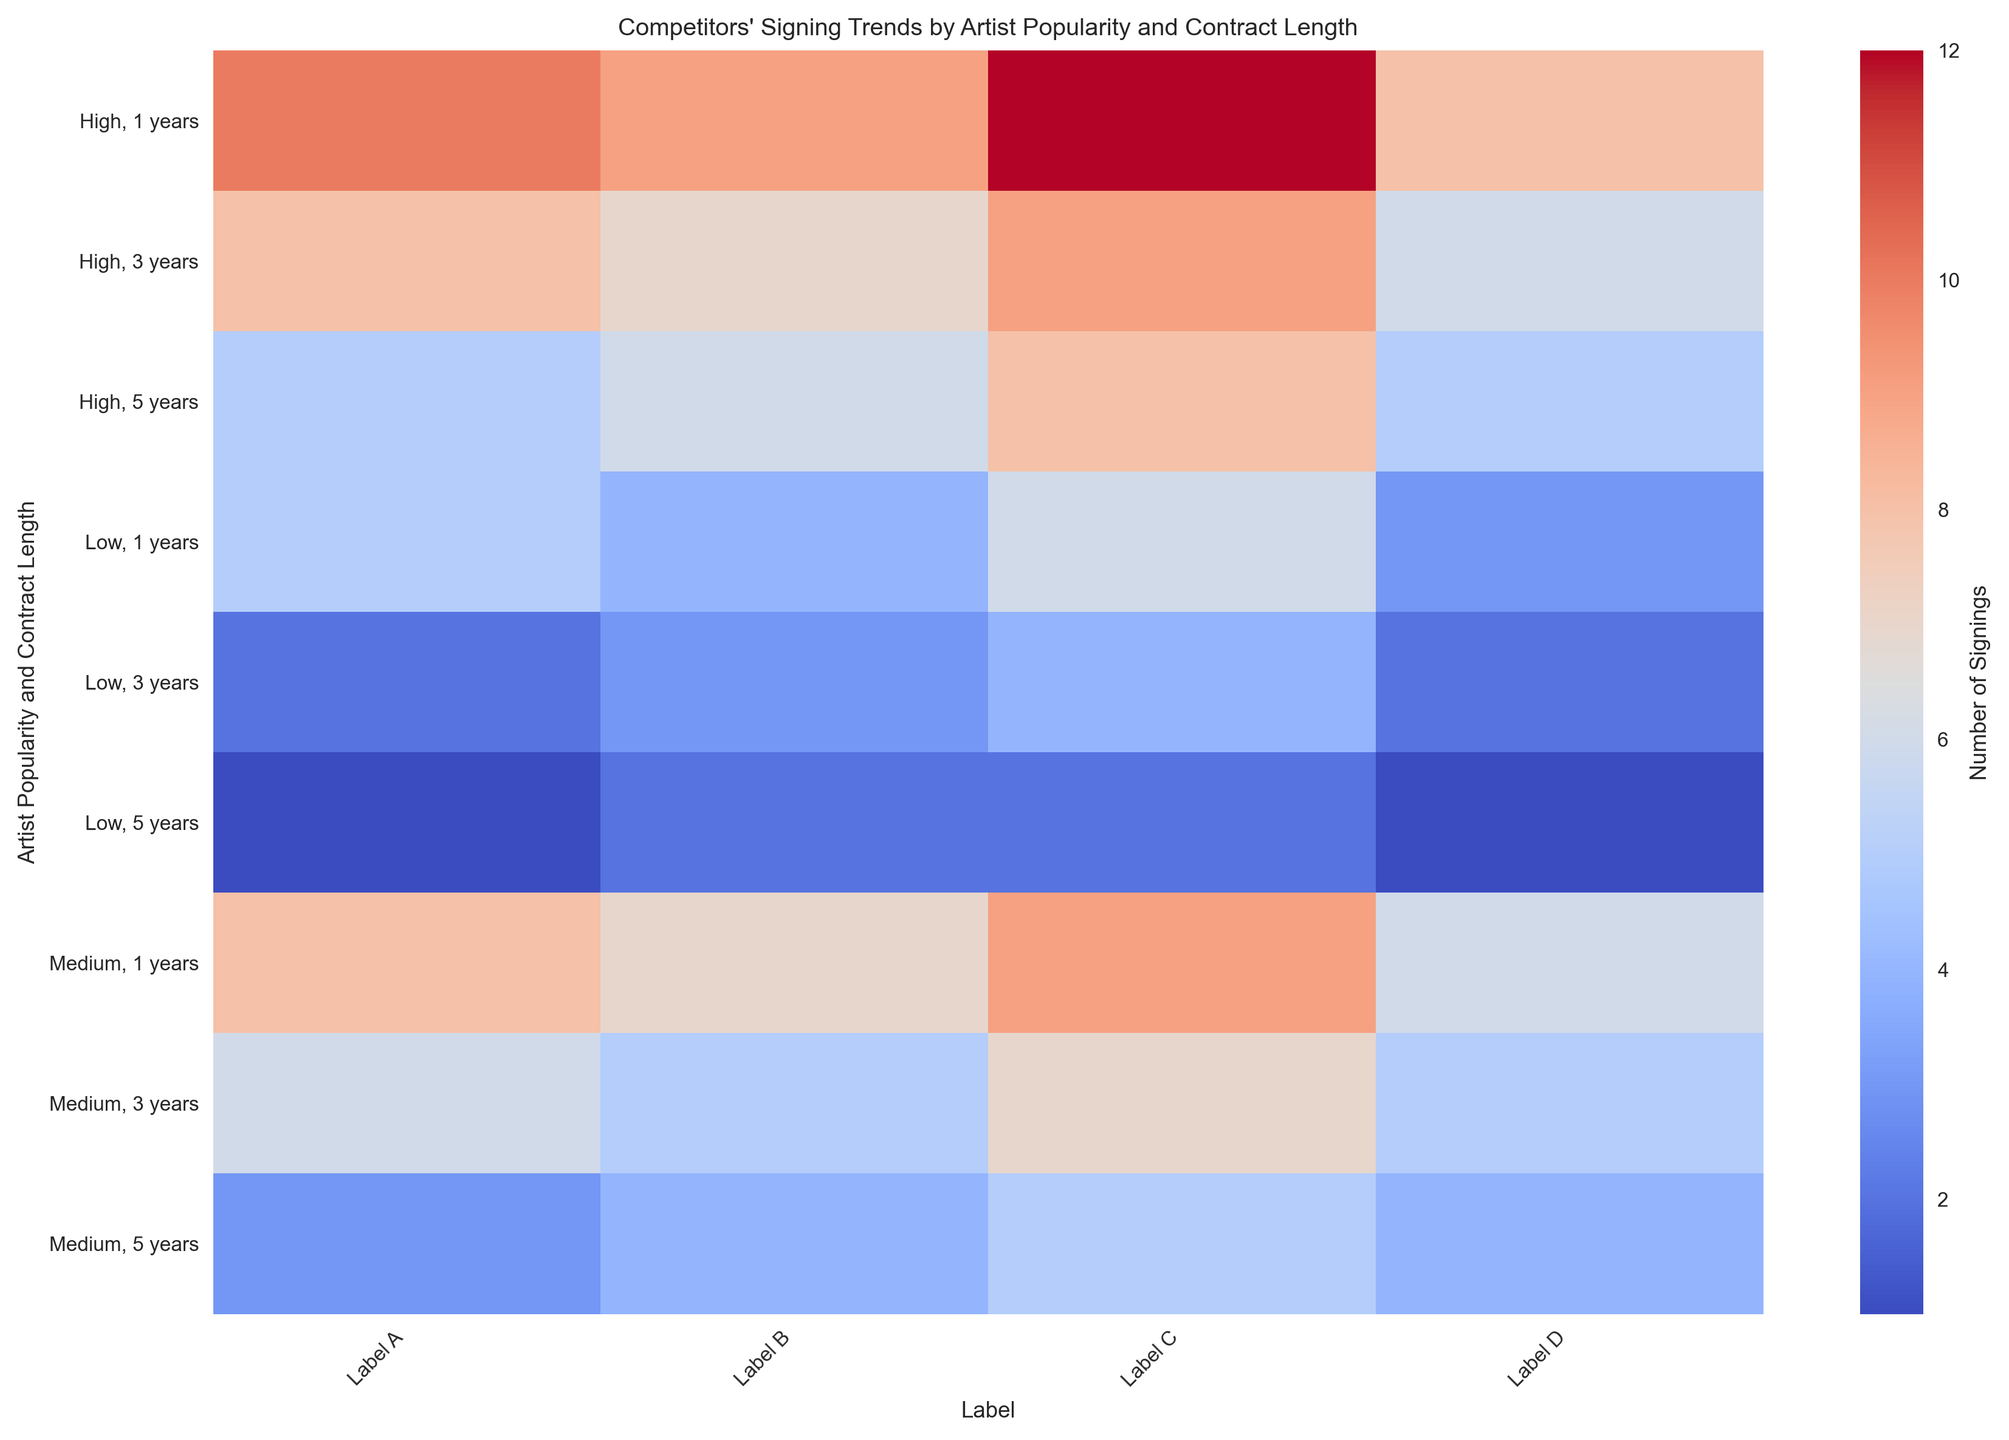What is the total number of signings for Label A across all categories? To find the total number of signings for Label A, sum the number of signings across all Artist Popularity and Contract Length categories: (5+2+1+8+6+3+10+8+5). The sum equals 48.
Answer: 48 Which label has the highest number of signings for high popularity artists with a 1-year contract? Look for the highest number of signings in the row corresponding to high popularity and 1-year contract. The values are 10 (Label A), 9 (Label B), 12 (Label C), and 8 (Label D). The highest is 12 for Label C.
Answer: Label C What is the average number of signings for Label B and Label D for medium popularity artists with a 3-year contract? Find the number of signings for Label B and Label D for medium popularity with a 3-year contract: Label B has 5, Label D has 5. The average is (5+5) / 2 = 5.
Answer: 5 Which label shows the most consistently lower signings across all categories? To determine the most consistently lower signings, visually scan for the label with consistently smaller numbers. Label D has consistently lower values across most categories (compared to other labels).
Answer: Label D How many more low popularity artists signed a 1-year contract with Label C compared to Label A? The number of signings for low popularity artists with a 1-year contract are 6 (Label C) and 5 (Label A). The difference is 6 - 5 = 1.
Answer: 1 Which label has more signings overall for high popularity artists, Label B or Label D? Sum the number of signings for high popularity artists for both labels: Label B (9+7+6) = 22, Label D (8+6+5) = 19. Label B has more signings overall.
Answer: Label B For medium popularity artists with a 5-year contract, which label has the fewest signings and by how much compared to the label with the most signings? The number of signings for medium popularity artists with a 5-year contract are 3 (Label A), 4 (Label B), 5 (Label C), and 4 (Label D). The fewest is 3 (Label A). The difference compared to the most (5, Label C) is 5 - 3 = 2.
Answer: 2 Which labels have an identical number of signings for high popularity artists with a 3-year contract? Look for matching values in the row for high popularity and 3-year contract: Labels A and D both have 8 signings. Label B has 7, and Label C has 9. So, A and D have identical numbers.
Answer: Label A, Label D 